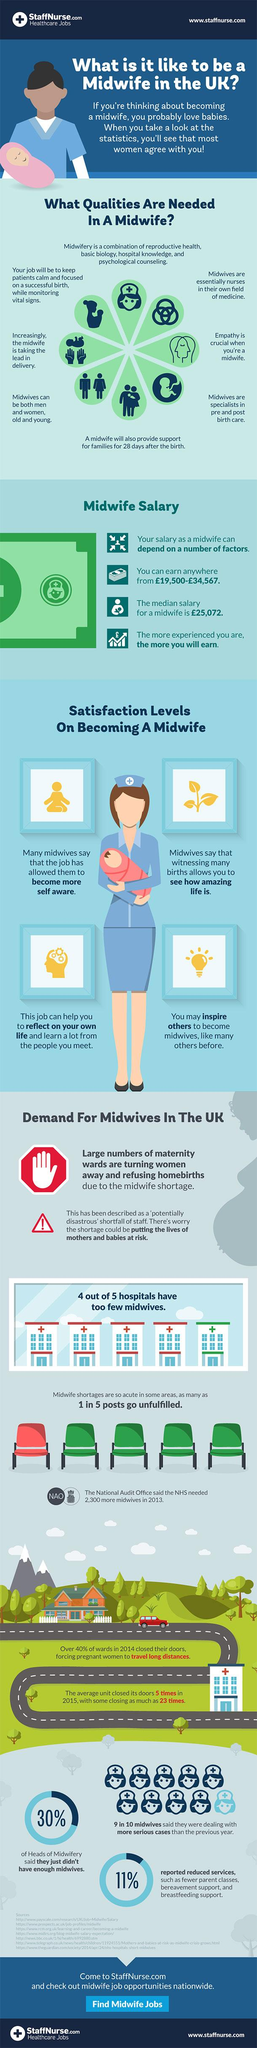Indicate a few pertinent items in this graphic. Ninety percent of the midwives in the sample of 10 believe that they are currently handling more complicated cases than they did last year. 